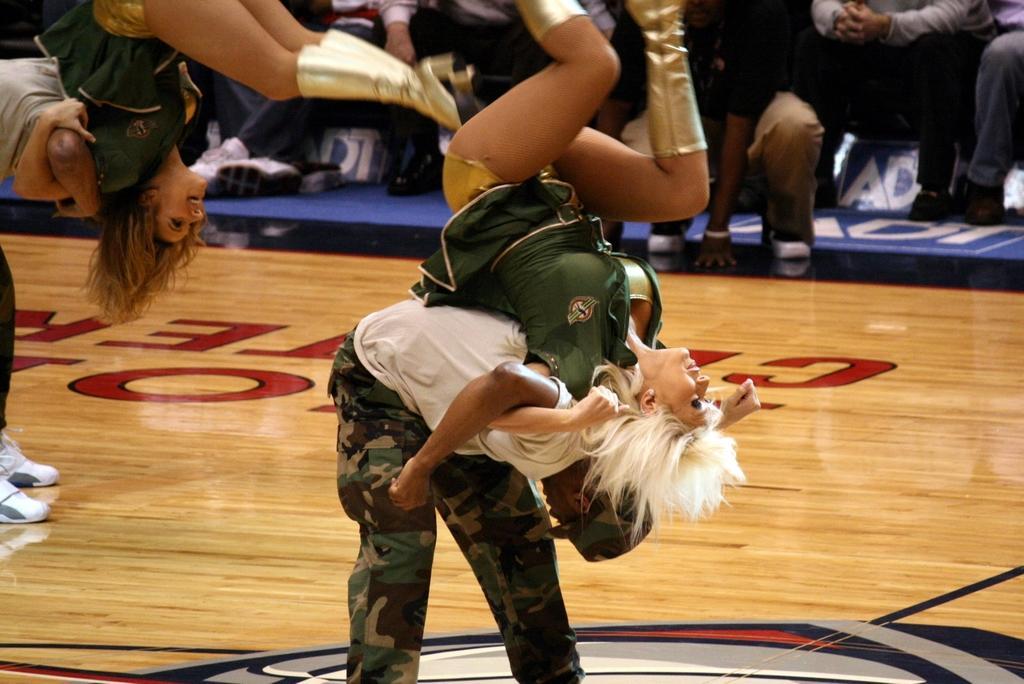Can you describe this image briefly? In the image in the center, we can see a few people are performing and they are in different costumes. In the background, we can see the banners and few people are sitting. 